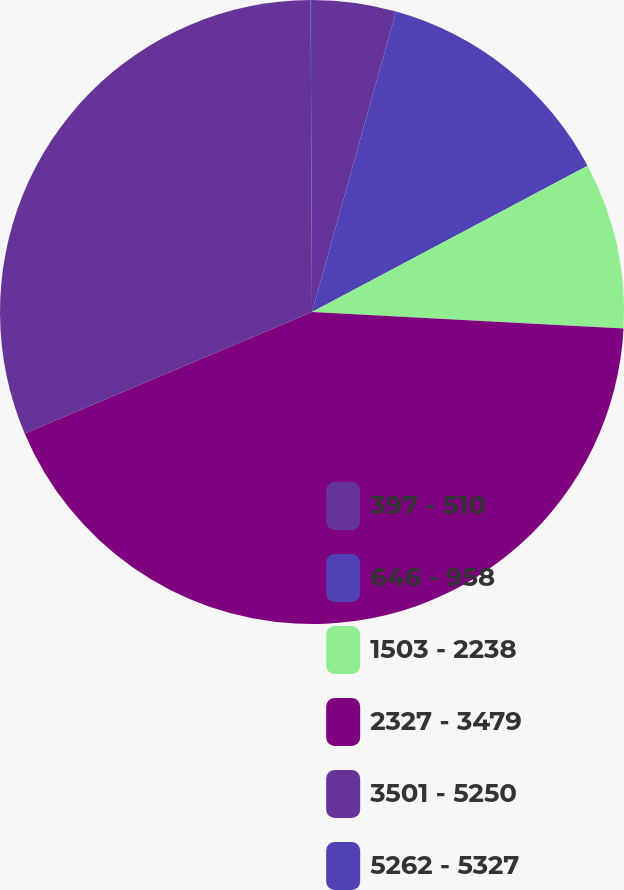Convert chart to OTSL. <chart><loc_0><loc_0><loc_500><loc_500><pie_chart><fcel>397 - 510<fcel>646 - 958<fcel>1503 - 2238<fcel>2327 - 3479<fcel>3501 - 5250<fcel>5262 - 5327<nl><fcel>4.34%<fcel>12.89%<fcel>8.61%<fcel>42.79%<fcel>31.3%<fcel>0.07%<nl></chart> 